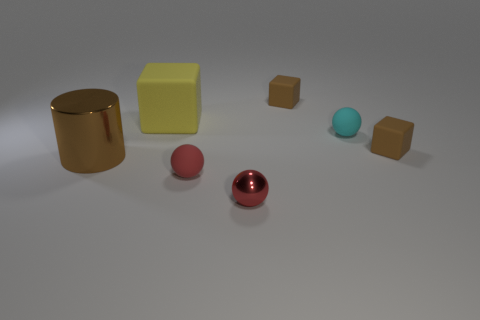Imagine this setting is part of a story. What narrative could you infer from the arrangement of these objects? Envisioning this as a setting in a story, one might see it as a metaphorical representation of characters or forces. The gold cylinder could symbolize wealth or status, standing firm and unyielding. The nearby red sphere may represent a character full of passion and energy, while the larger sphere behind it suggests a looming presence or influence. The turquoise sphere might be a newcomer or a stranger to this group, and the brown cubes could symbolize the ordinary or mundane elements of life. Together, they weave a narrative of interaction and contrast, highlighting themes of diversity, influence, and the roles each 'character' plays in the tableau. 